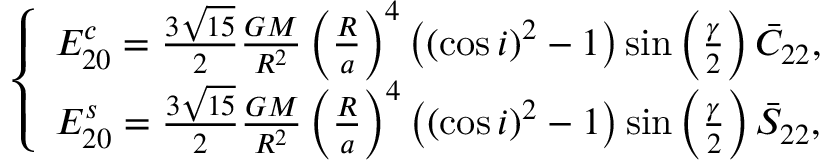<formula> <loc_0><loc_0><loc_500><loc_500>\left \{ \begin{array} { c } { E _ { 2 0 } ^ { c } = \frac { 3 \sqrt { 1 5 } } { 2 } \frac { G M } { R ^ { 2 } } \left ( \frac { R } { a } \right ) ^ { 4 } \left ( ( \cos i ) ^ { 2 } - 1 \right ) \sin \left ( \frac { \gamma } { 2 } \right ) \bar { C } _ { 2 2 } , } \\ { E _ { 2 0 } ^ { s } = \frac { 3 \sqrt { 1 5 } } { 2 } \frac { G M } { R ^ { 2 } } \left ( \frac { R } { a } \right ) ^ { 4 } \left ( ( \cos i ) ^ { 2 } - 1 \right ) \sin \left ( \frac { \gamma } { 2 } \right ) \bar { S } _ { 2 2 } , } \end{array}</formula> 